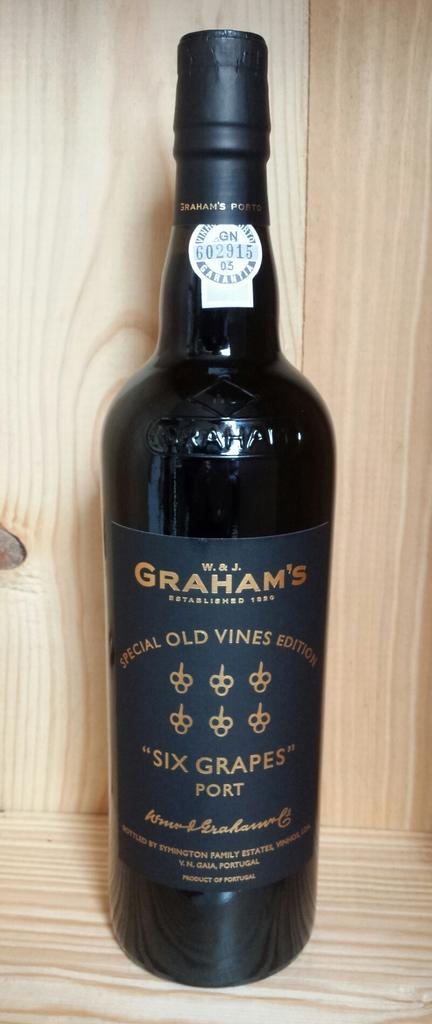What is the brand displayed in the wine's bottle?
Keep it short and to the point. Graham's. What type of wine is this?
Offer a terse response. Port. 